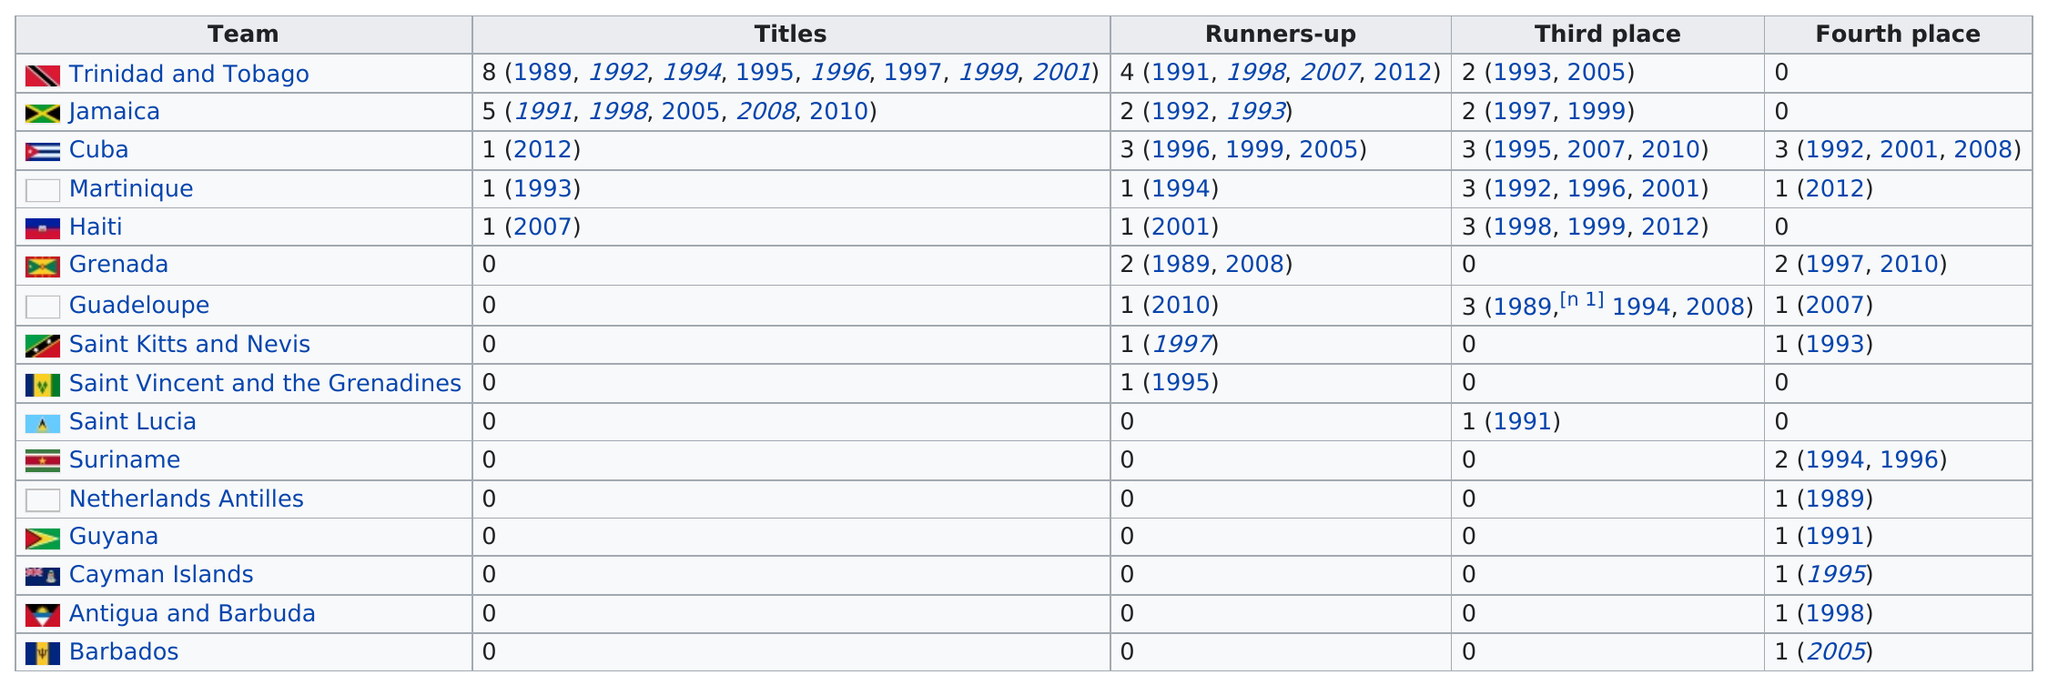Draw attention to some important aspects in this diagram. Jamaica has won three titles since Trinidad and Tobago's last title. Jamaica has the highest percentage of winning titles relative to runner-up finishes, indicating their dominance in the sport. The Caribbean Cup has been won by several teams, including Trinidad and Tobago, Jamaica, Cuba, Martinique, and Haiti. 